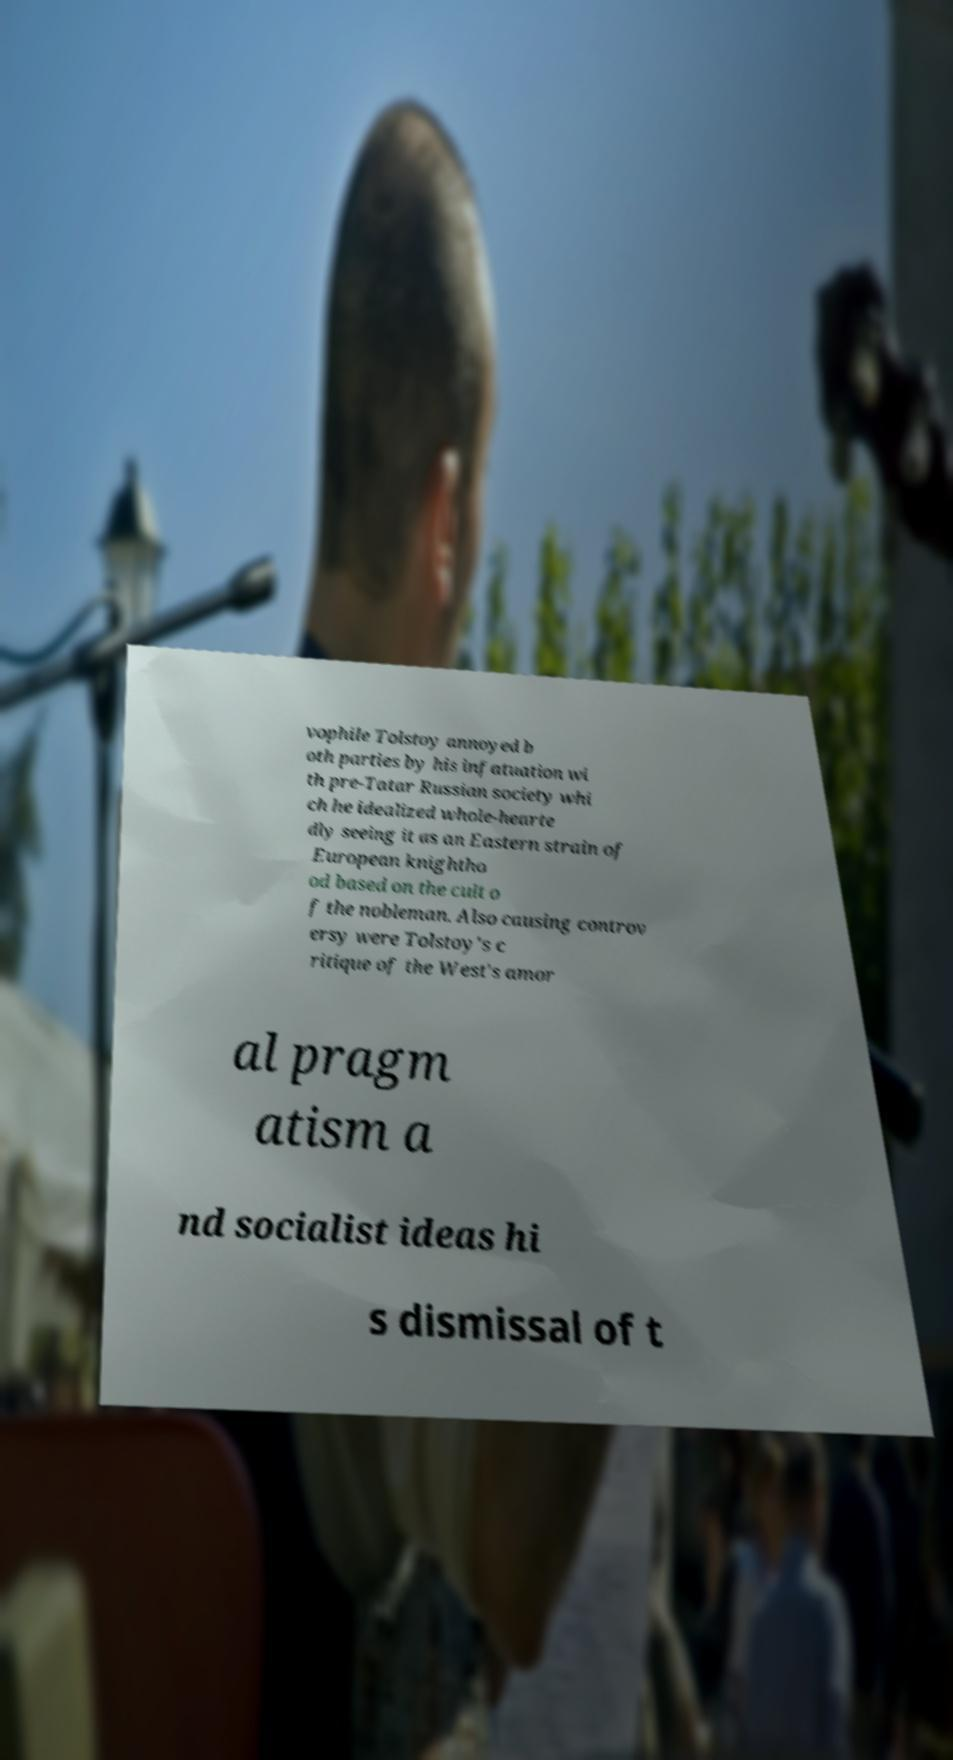Could you assist in decoding the text presented in this image and type it out clearly? vophile Tolstoy annoyed b oth parties by his infatuation wi th pre-Tatar Russian society whi ch he idealized whole-hearte dly seeing it as an Eastern strain of European knightho od based on the cult o f the nobleman. Also causing controv ersy were Tolstoy's c ritique of the West's amor al pragm atism a nd socialist ideas hi s dismissal of t 